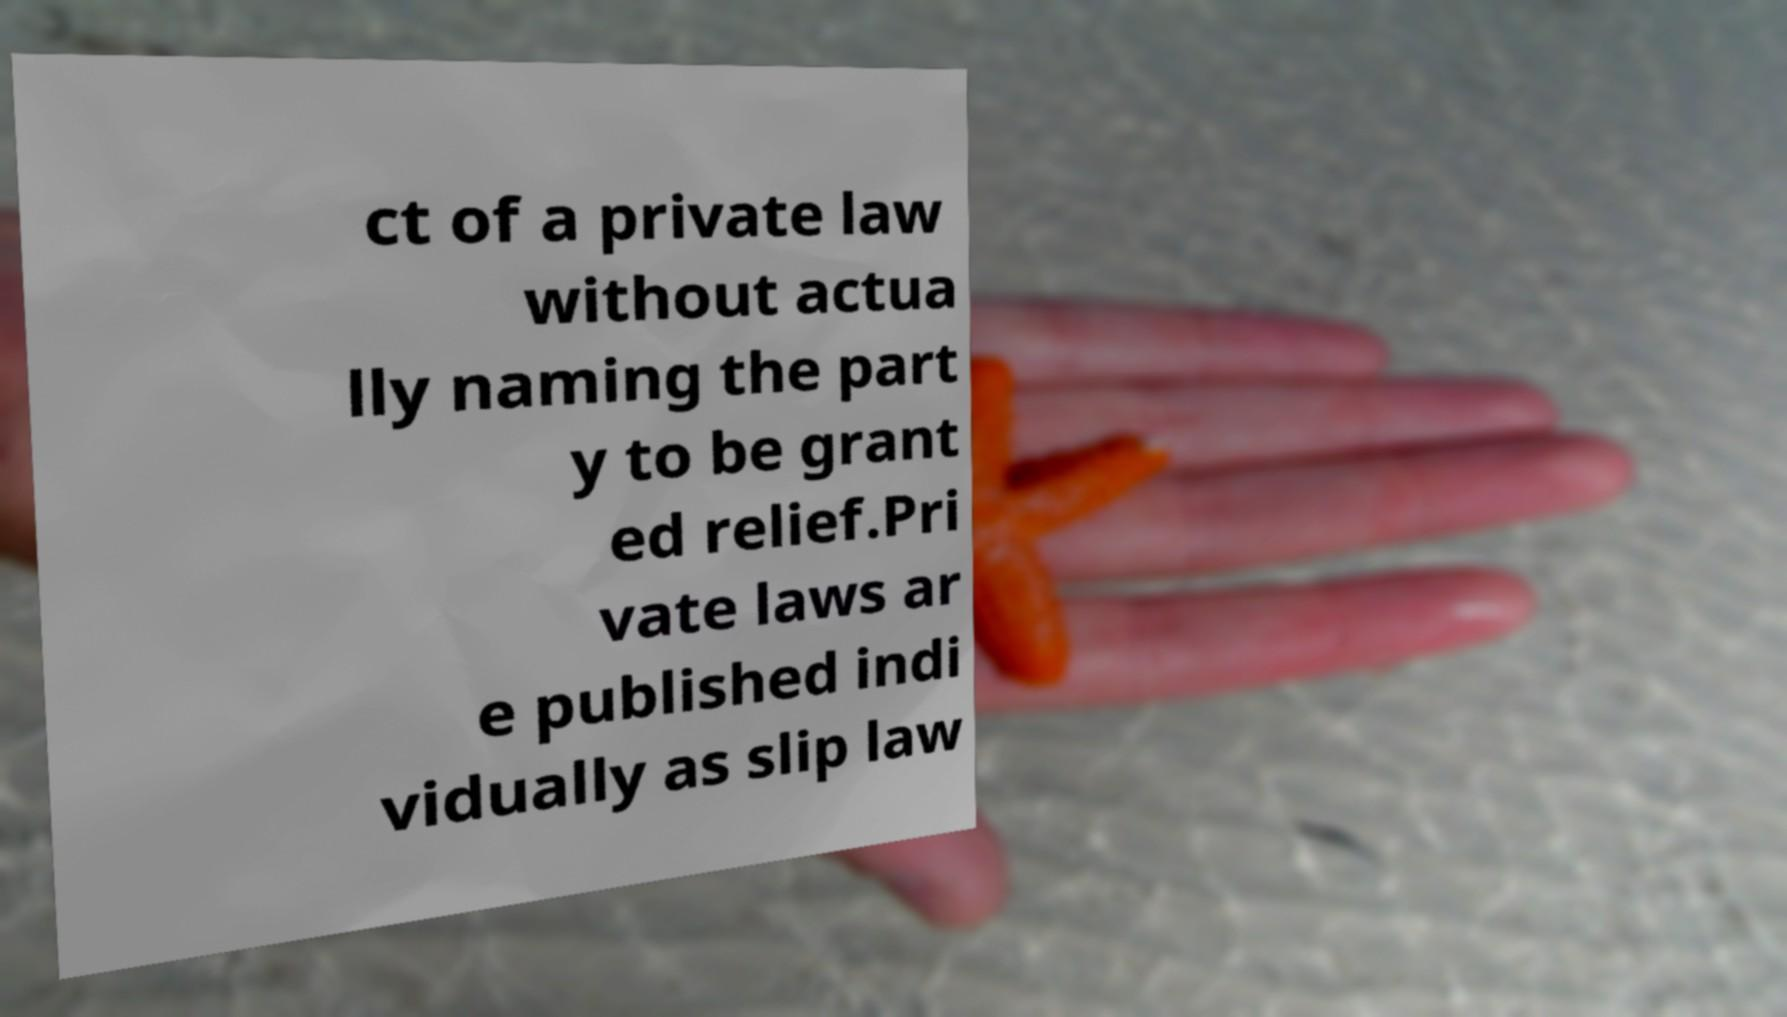Can you accurately transcribe the text from the provided image for me? ct of a private law without actua lly naming the part y to be grant ed relief.Pri vate laws ar e published indi vidually as slip law 